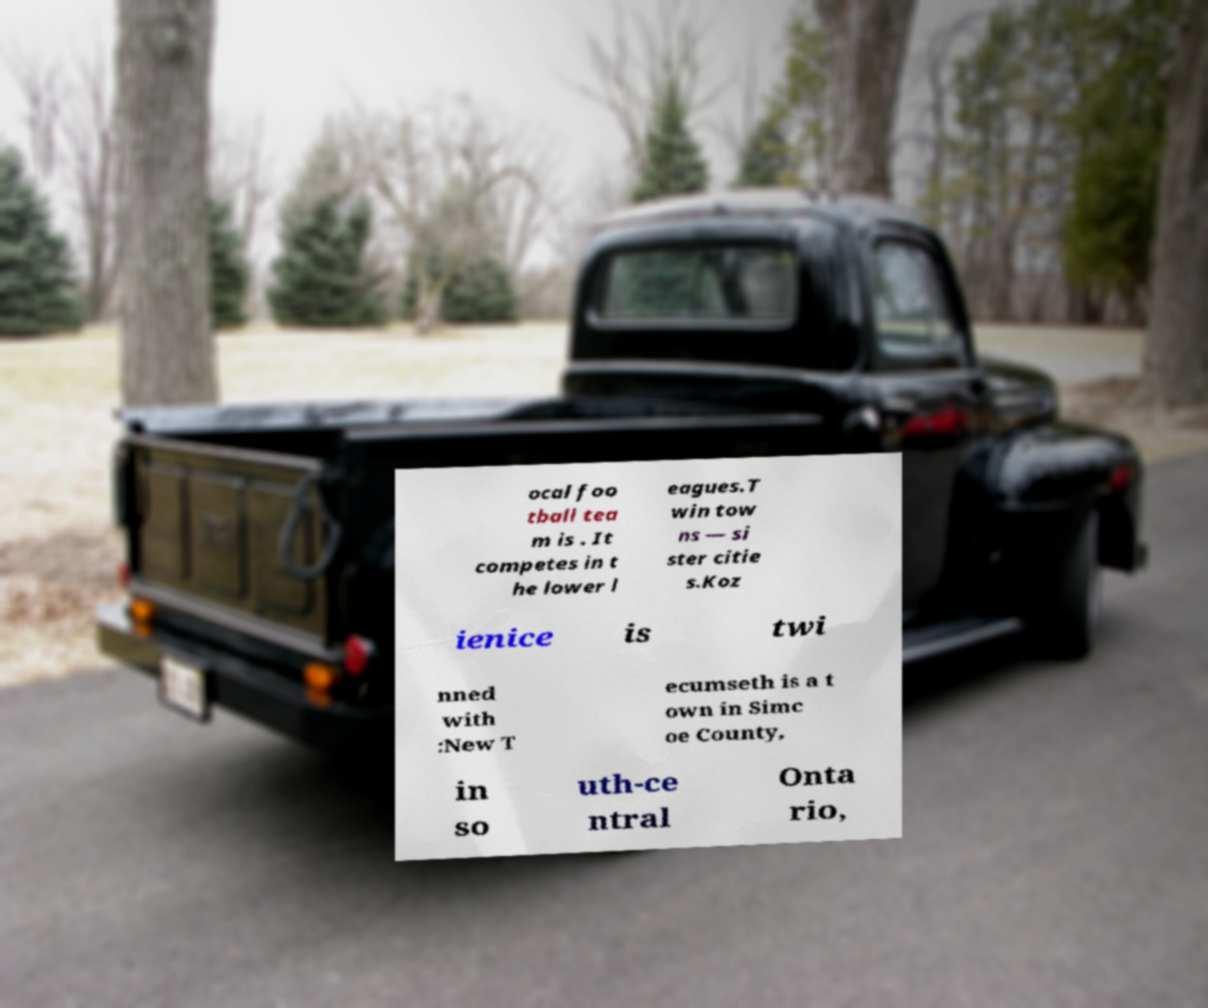Can you accurately transcribe the text from the provided image for me? ocal foo tball tea m is . It competes in t he lower l eagues.T win tow ns — si ster citie s.Koz ienice is twi nned with :New T ecumseth is a t own in Simc oe County, in so uth-ce ntral Onta rio, 